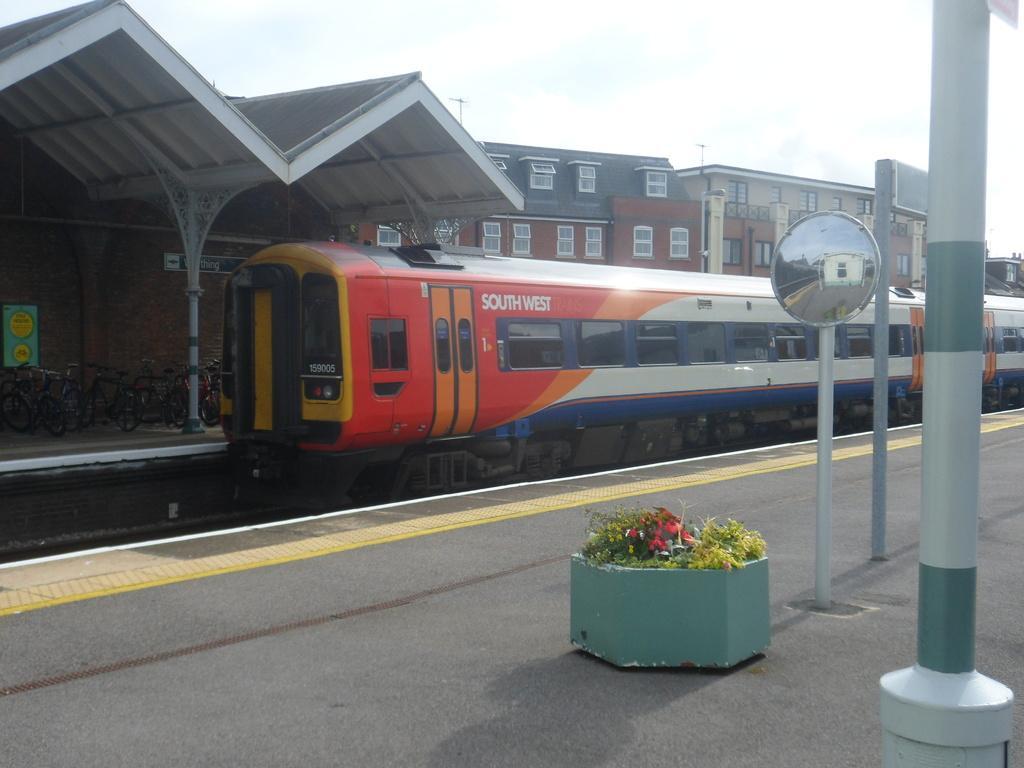Describe this image in one or two sentences. In this picture I can see a train on the railway track, there are bicycles, flower pot and a traffic mirror on the platforms, there are buildings, and in the background there is the sky. 